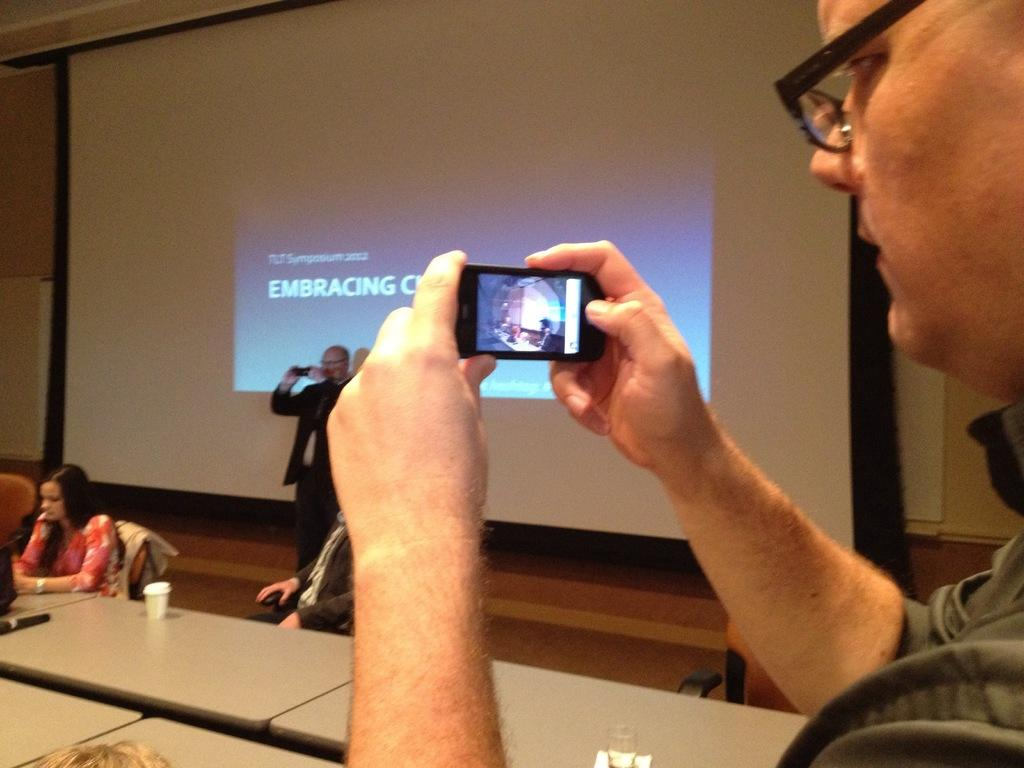What is the person in the image holding? The person in the image is holding a mobile. What are the people in front of the person holding the mobile doing? The people in front of the person holding the mobile are sitting. What is the person standing in front of in the image? The person standing in front of a screen in the image. What type of wool is being used to drain the sense in the image? There is no wool, drain, or sense present in the image. 